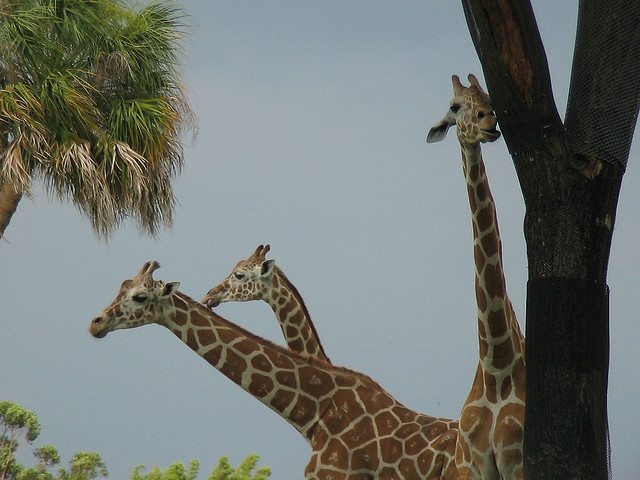Describe the objects in this image and their specific colors. I can see giraffe in gray, maroon, and black tones, giraffe in gray and black tones, and giraffe in gray and black tones in this image. 